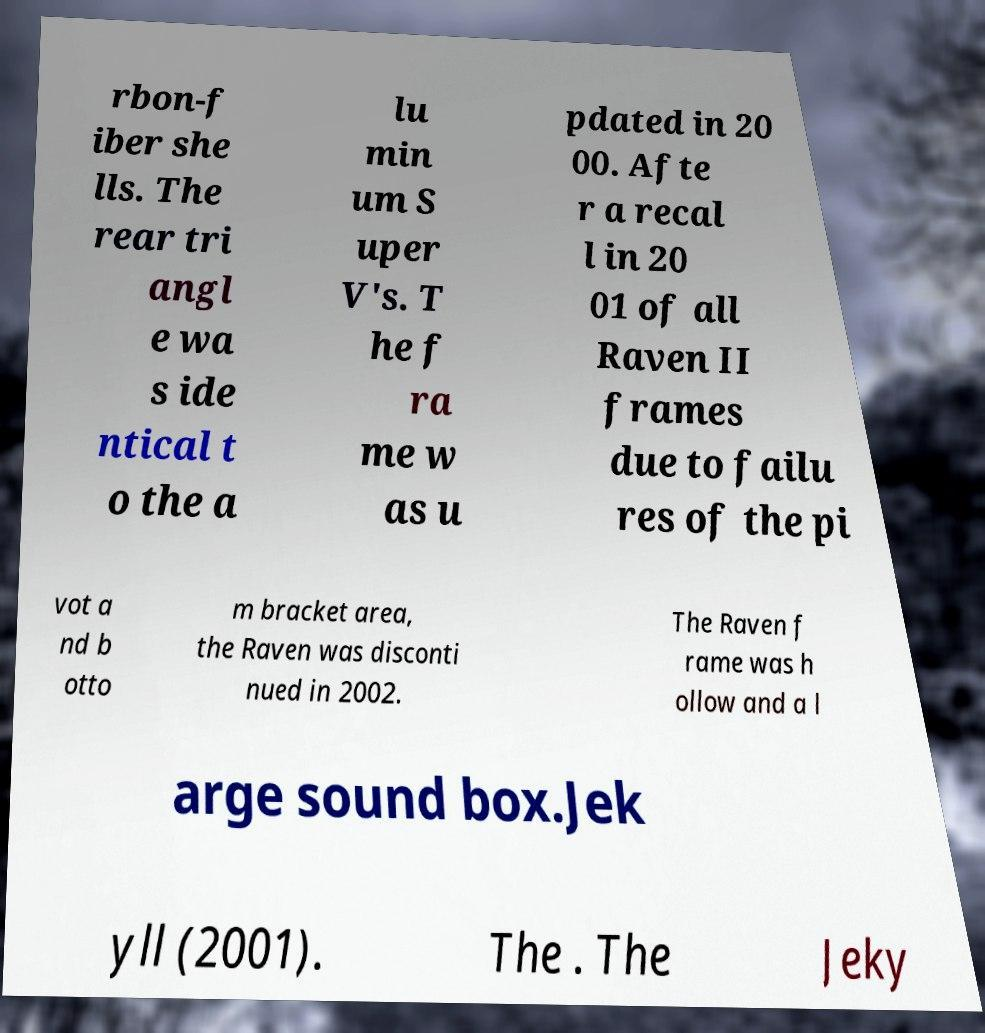There's text embedded in this image that I need extracted. Can you transcribe it verbatim? rbon-f iber she lls. The rear tri angl e wa s ide ntical t o the a lu min um S uper V's. T he f ra me w as u pdated in 20 00. Afte r a recal l in 20 01 of all Raven II frames due to failu res of the pi vot a nd b otto m bracket area, the Raven was disconti nued in 2002. The Raven f rame was h ollow and a l arge sound box.Jek yll (2001). The . The Jeky 